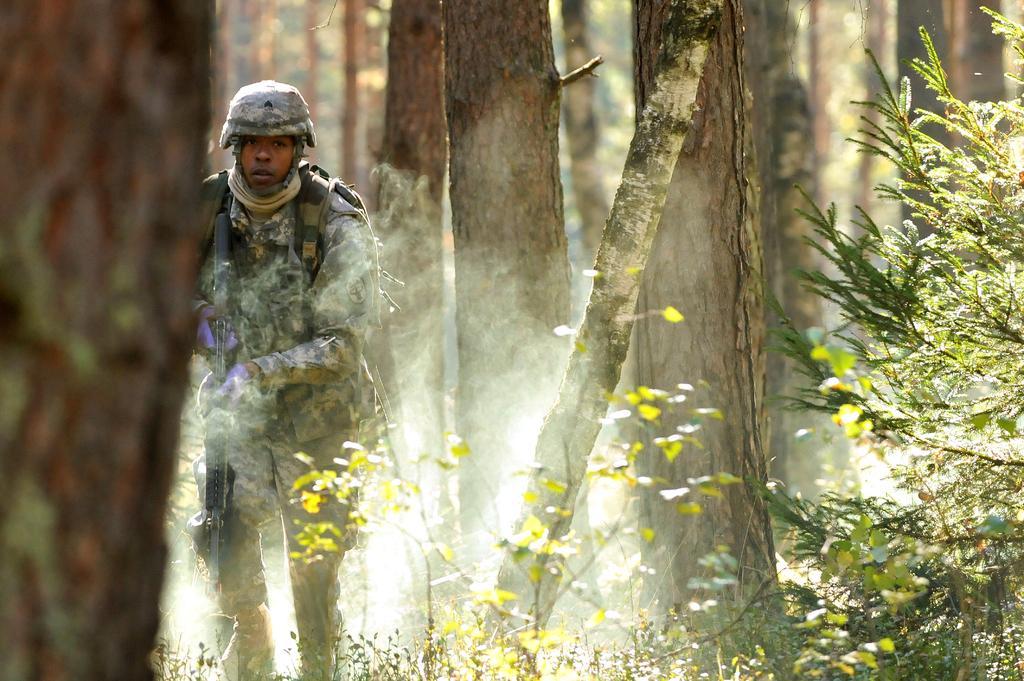Describe this image in one or two sentences. On the left side of the image there is a tree trunk. Beside the trunk there is a man with uniform, helmet in his head and he is holding a gun in his hand. On the right side of the image there are plants with leaves. In the background there are tree trunks. 